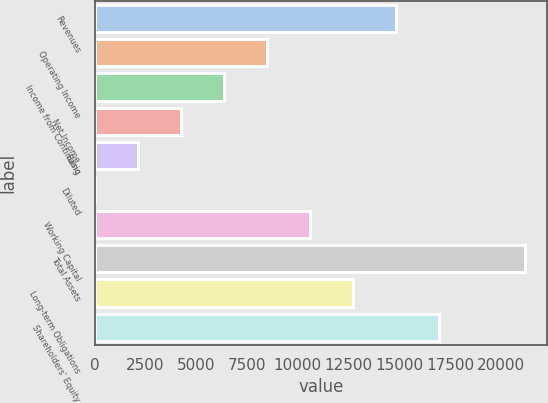Convert chart. <chart><loc_0><loc_0><loc_500><loc_500><bar_chart><fcel>Revenues<fcel>Operating Income<fcel>Income from Continuing<fcel>Net Income<fcel>Basic<fcel>Diluted<fcel>Working Capital<fcel>Total Assets<fcel>Long-term Obligations<fcel>Shareholders' Equity<nl><fcel>14845.7<fcel>8484<fcel>6363.44<fcel>4242.88<fcel>2122.32<fcel>1.76<fcel>10604.6<fcel>21207.4<fcel>12725.1<fcel>16966.2<nl></chart> 